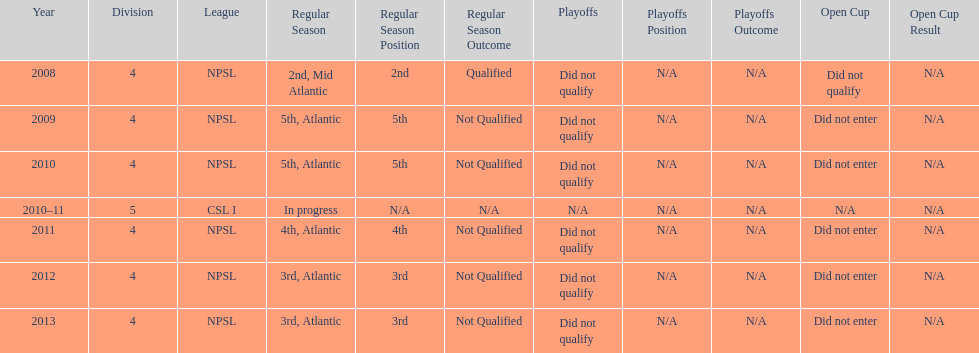In what year only did they compete in division 5 2010-11. 